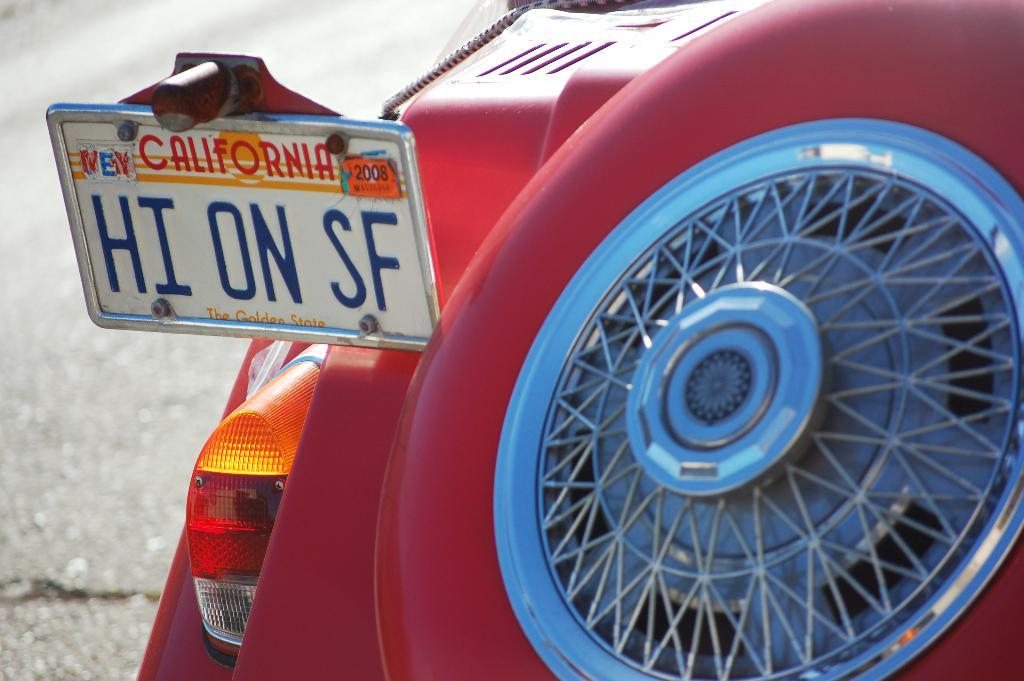What is the color of the object that stands out in the image? There is a red object in the image. What is written or depicted on the board in the image? There is a board with text in the image. Can you describe the wheel-like object on the right side of the image? There is a wheel-like object on the right side of the image. How does the rhythm of the coach affect the red object in the image? There is no coach or rhythm present in the image, so this question cannot be answered. 